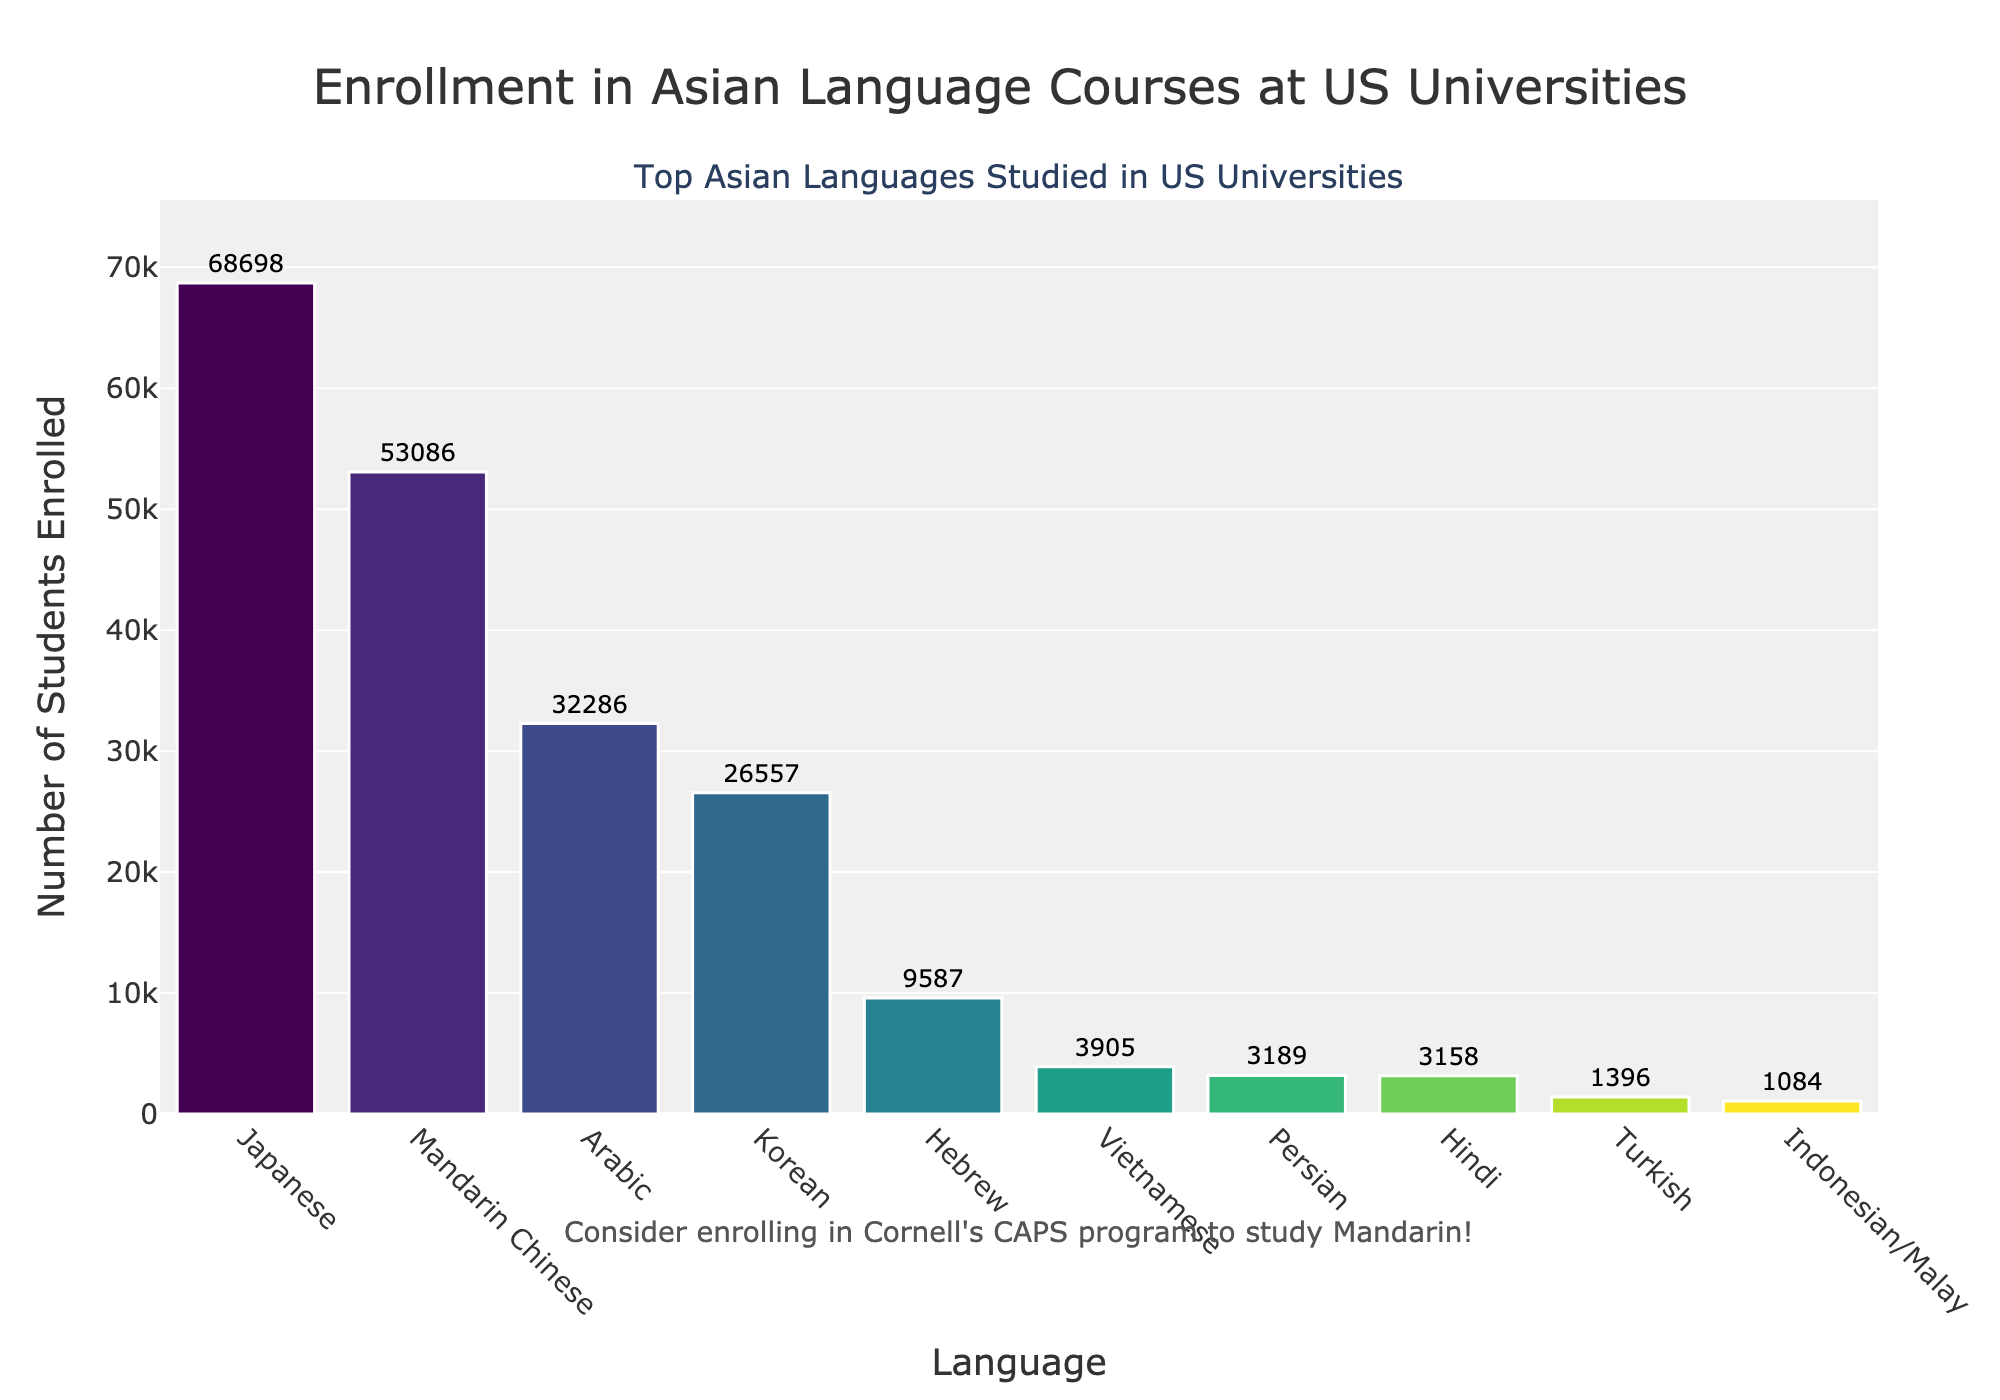Which language has the highest enrollment and what is the value? Looking at the highest bar on the chart, Japanese has the highest enrollment. The enrollment value indicated by the text outside the bar is 68,698.
Answer: Japanese, 68,698 What is the total enrollment for Mandarin Chinese and Korean? By adding the enrollment figures for Mandarin Chinese (53,086) and Korean (26,557), we get 53,086 + 26,557 = 79,643.
Answer: 79,643 How does the enrollment for Arabic compare to Hebrew? The chart shows Arabic with an enrollment of 32,286 and Hebrew with 9,587. Arabic's enrollment is significantly higher than Hebrew's.
Answer: Arabic is higher Which language has the lowest enrollment, and what is the enrollment number? The smallest bar corresponds to Indonesian/Malay with an enrollment of 1,084.
Answer: Indonesian/Malay, 1,084 Is the enrollment for Hindi higher or lower than for Vietnamese? The chart indicates Hindi's enrollment at 3,158 and Vietnamese's at 3,905. Hindi's enrollment is lower than Vietnamese's.
Answer: Lower What is the difference in enrollment between the second and third most studied languages? Japanese is the top language, followed by Mandarin Chinese with 53,086 enrollments and Korean with 26,557 enrollments. The difference is 53,086 - 26,557 = 26,529.
Answer: 26,529 What is the average enrollment of the top three languages? The top three languages are Japanese (68,698), Mandarin Chinese (53,086), and Korean (26,557). The total enrollment is 68,698 + 53,086 + 26,557 = 148,341. The average is 148,341 / 3 = 49,447.
Answer: 49,447 How much higher is Hebrew's enrollment compared to Turkish's? Hebrew's enrollment is 9,587 and Turkish's is 1,396. The difference is 9,587 - 1,396 = 8,191.
Answer: 8,191 What is the sum of enrollments for Persian and Vietnamese? The enrollments are 3,189 for Persian and 3,905 for Vietnamese. The sum is 3,189 + 3,905 = 7,094.
Answer: 7,094 Which language bar is just above the y-axis midpoint, and what does this signify? The midpoint of the y-axis can be estimated by halving the highest value (~68,698 / 2 ≈ 34,349). Arabic, with an enrollment of 32,286, is close to this value but slightly below it, indicating it is around the median enrollment compared to others.
Answer: Arabic 